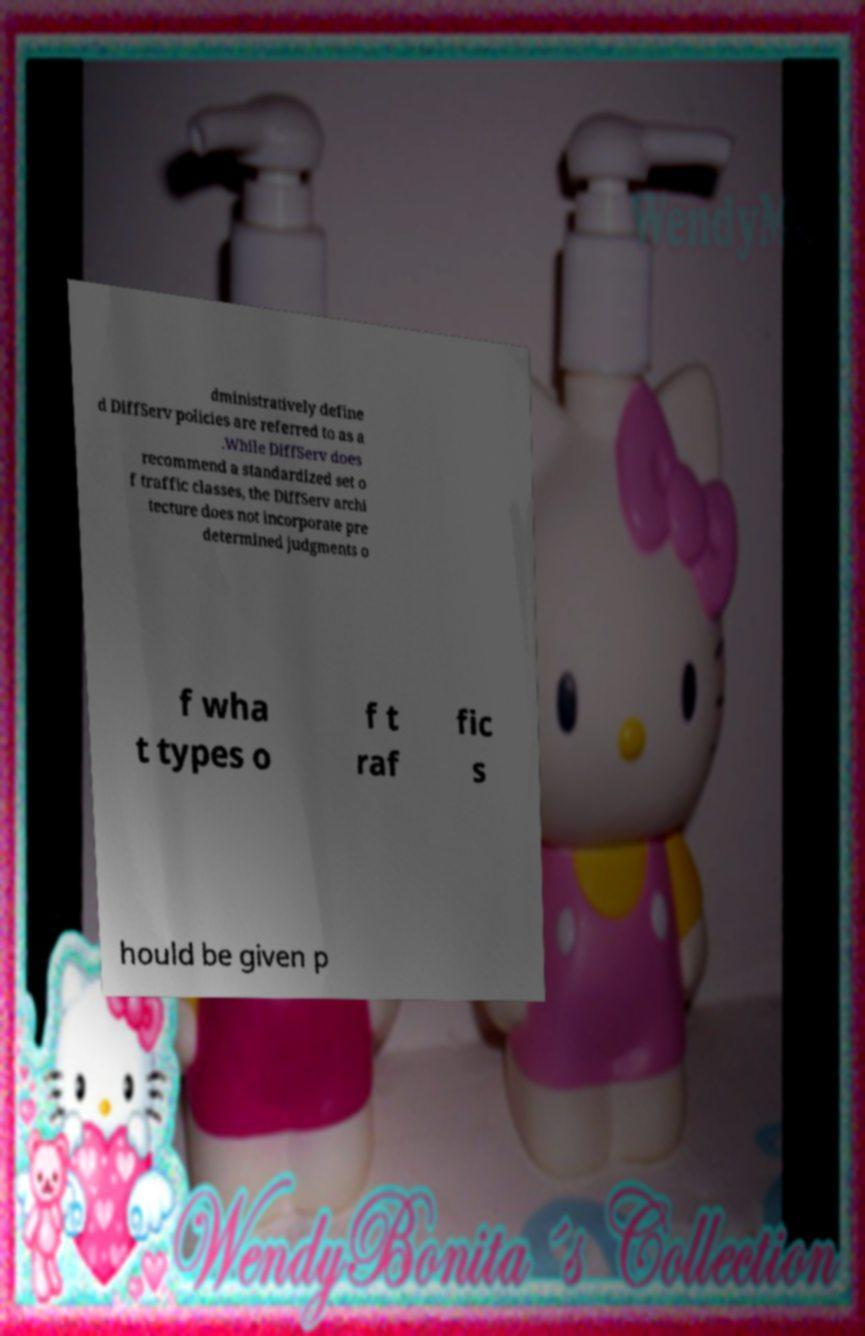For documentation purposes, I need the text within this image transcribed. Could you provide that? dministratively define d DiffServ policies are referred to as a .While DiffServ does recommend a standardized set o f traffic classes, the DiffServ archi tecture does not incorporate pre determined judgments o f wha t types o f t raf fic s hould be given p 